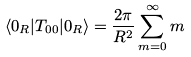<formula> <loc_0><loc_0><loc_500><loc_500>\langle 0 _ { R } | T _ { 0 0 } | 0 _ { R } \rangle = { \frac { 2 \pi } { R ^ { 2 } } } \sum _ { m = 0 } ^ { \infty } m</formula> 